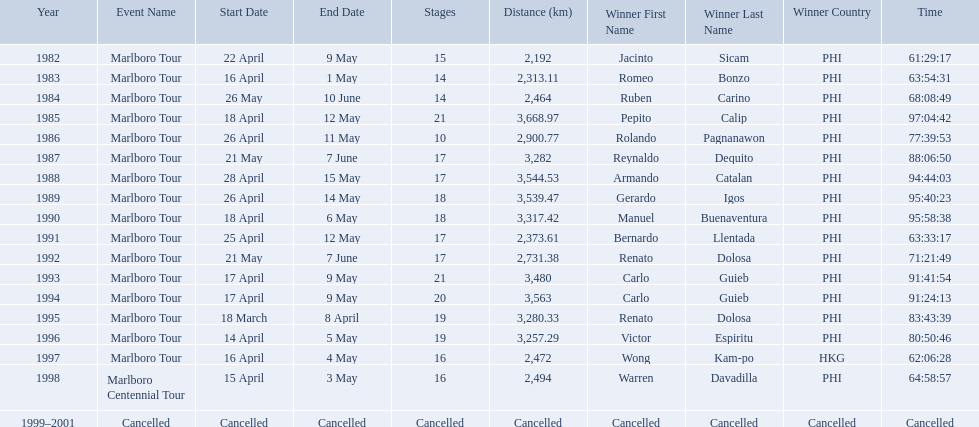What are the distances travelled on the tour? 2,192 km, 2,313.11 km, 2,464 km, 3,668.97 km, 2,900.77 km, 3,282 km, 3,544.53 km, 3,539.47 km, 3,317.42 km, 2,373.61 km, 2,731.38 km, 3,480 km, 3,563 km, 3,280.33 km, 3,257.29 km, 2,472 km, 2,494 km. Which of these are the largest? 3,668.97 km. What were the tour names during le tour de filipinas? Marlboro Tour, Marlboro Tour, Marlboro Tour, Marlboro Tour, Marlboro Tour, Marlboro Tour, Marlboro Tour, Marlboro Tour, Marlboro Tour, Marlboro Tour, Marlboro Tour, Marlboro Tour, Marlboro Tour, Marlboro Tour, Marlboro Tour, Marlboro Tour, Marlboro Centennial Tour, Cancelled. What were the recorded distances for each marlboro tour? 2,192 km, 2,313.11 km, 2,464 km, 3,668.97 km, 2,900.77 km, 3,282 km, 3,544.53 km, 3,539.47 km, 3,317.42 km, 2,373.61 km, 2,731.38 km, 3,480 km, 3,563 km, 3,280.33 km, 3,257.29 km, 2,472 km. And of those distances, which was the longest? 3,668.97 km. Which year did warren davdilla (w.d.) appear? 1998. What tour did w.d. complete? Marlboro Centennial Tour. What is the time recorded in the same row as w.d.? 64:58:57. 